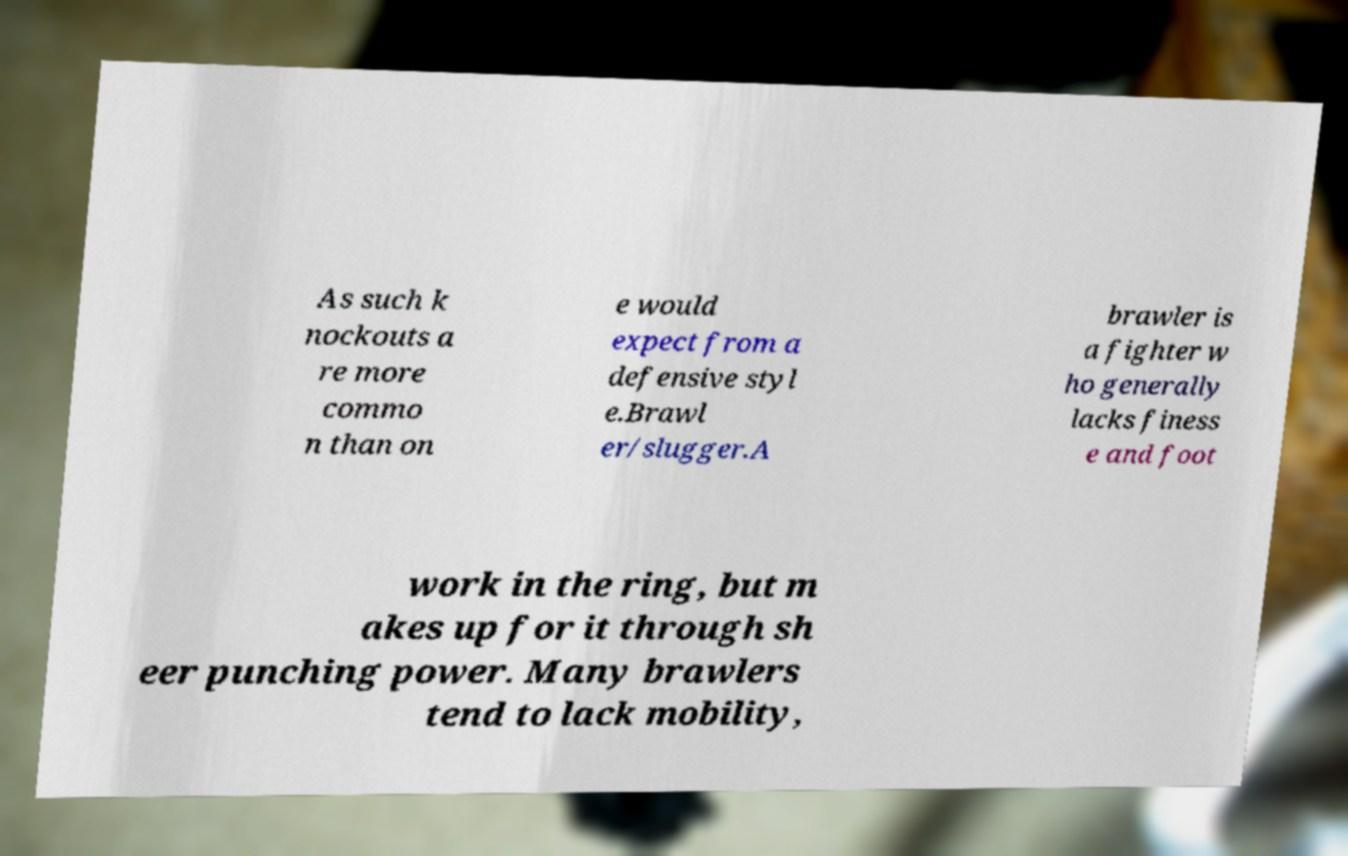I need the written content from this picture converted into text. Can you do that? As such k nockouts a re more commo n than on e would expect from a defensive styl e.Brawl er/slugger.A brawler is a fighter w ho generally lacks finess e and foot work in the ring, but m akes up for it through sh eer punching power. Many brawlers tend to lack mobility, 